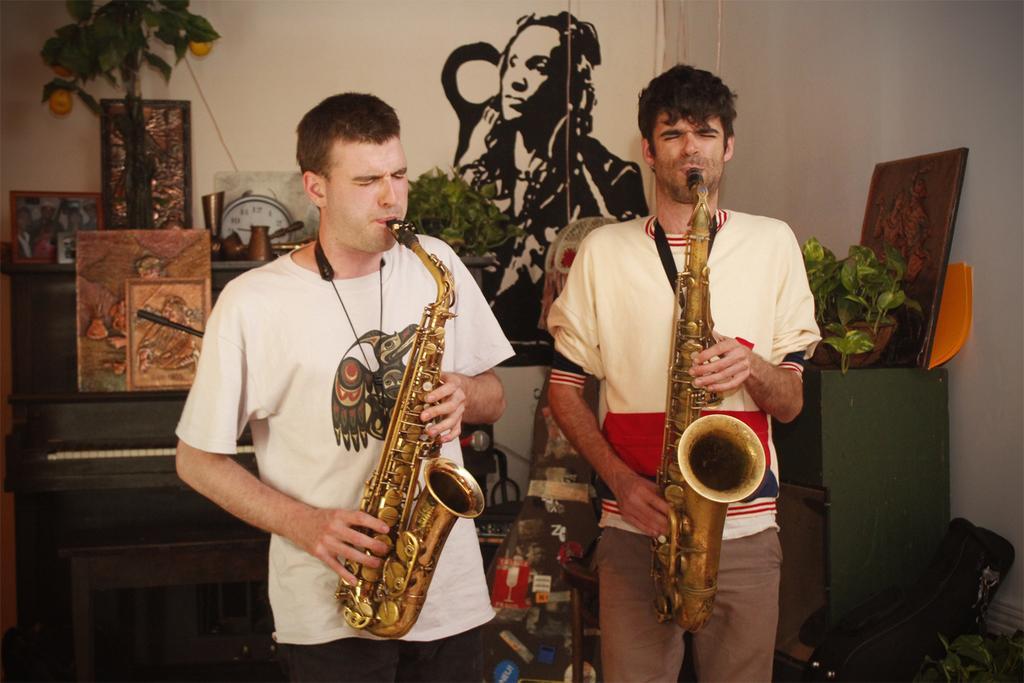How would you summarize this image in a sentence or two? In this image I can see there are two persons holding musical instrument and playing a music and backside of them there is the wall, in front of the wall there is a photo frame, plants, flower pots visible and there is the wall on the right side and in front of wall there is a photo frame , flower pot and a plant. 